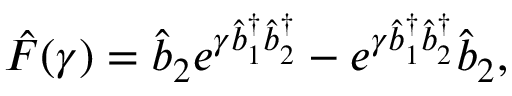<formula> <loc_0><loc_0><loc_500><loc_500>\hat { F } ( \gamma ) = \hat { b } _ { 2 } e ^ { \gamma \hat { b } _ { 1 } ^ { \dagger } \hat { b } _ { 2 } ^ { \dagger } } - e ^ { \gamma \hat { b } _ { 1 } ^ { \dagger } \hat { b } _ { 2 } ^ { \dagger } } \hat { b } _ { 2 } ,</formula> 